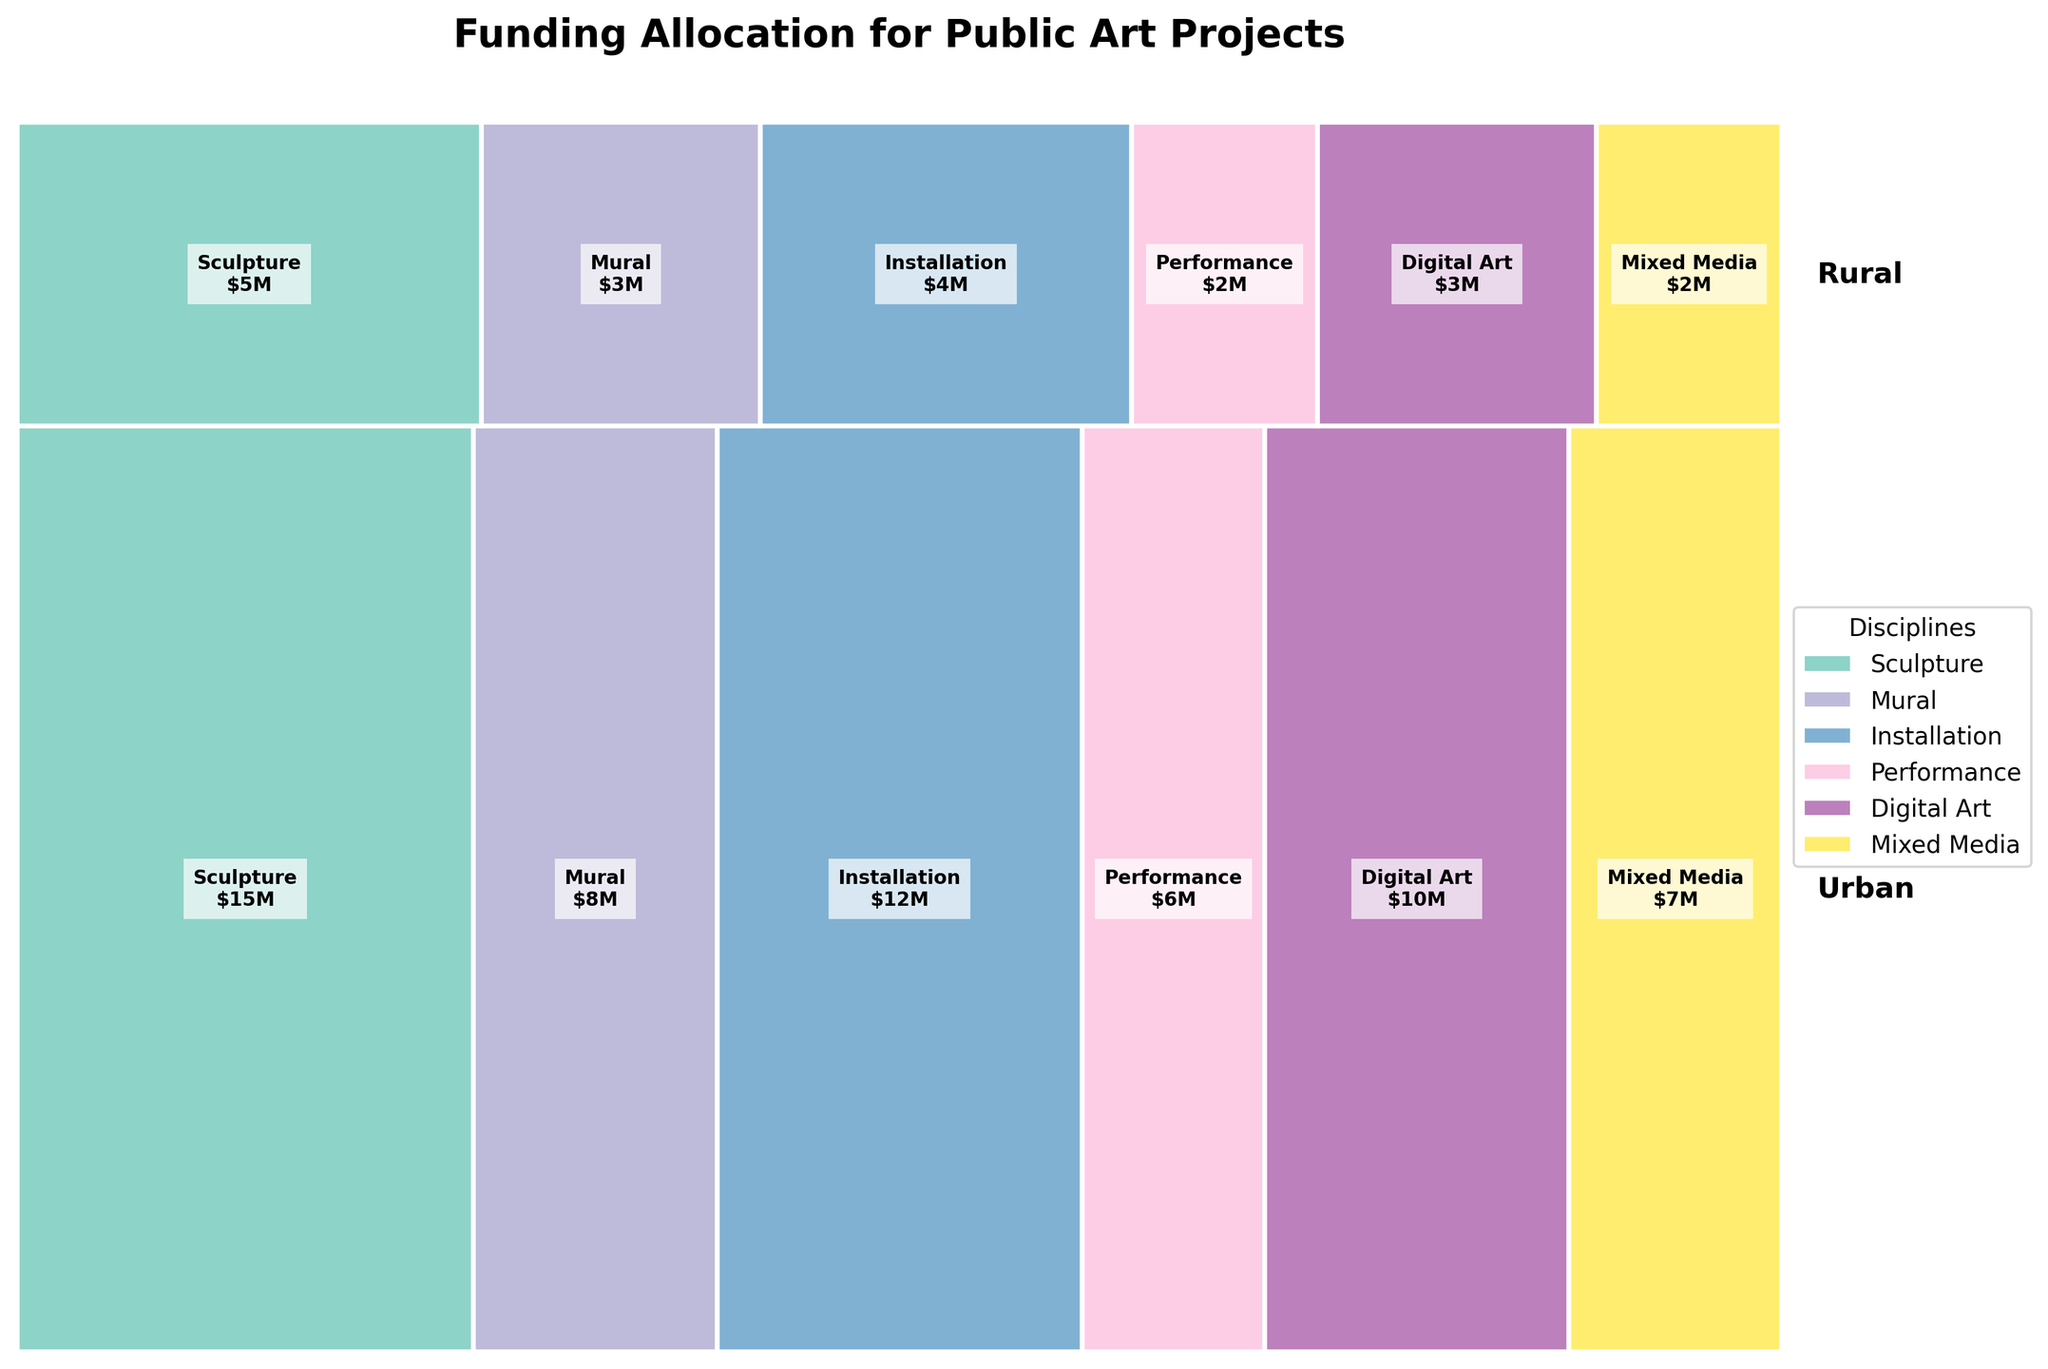what's the title of the figure? The title is located at the top of the figure and usually describes the main topic or message of the plot. It helps viewers understand the context.
Answer: Funding Allocation for Public Art Projects Which area received more total funding, Urban or Rural? Compare the total areas occupied by the sections labeled 'Urban' and 'Rural'. The total height of the 'Urban' sections is larger than that of the 'Rural' sections, indicating more total funding.
Answer: Urban What is the discipline with the highest funding in Urban areas? Within the 'Urban' sections, locate the section with the largest width. The section labeled 'Sculpture' is the widest, indicating it has the highest funding.
Answer: Sculpture Compare the funding allocated to Digital Art in Urban areas vs. Rural areas. Which one received more, and by how much? Check the sections labeled 'Digital Art' in both 'Urban' and 'Rural' areas. The 'Urban' section is wider, representing more funding. The difference is $10M - $3M = $7M.
Answer: Urban by $7M What is the total funding allocated to Mixed Media projects? Locate both 'Urban' and 'Rural' sections labeled 'Mixed Media' and add their funding values: $7M (Urban) + $2M (Rural) = $9M.
Answer: $9M How does the funding for Sculpture compare between Urban and Rural areas? For 'Sculpture', compare the widths of 'Urban' and 'Rural' sections. Urban's section is significantly wider than Rural's. $15M (Urban) vs. $5M (Rural), so Urban has $10M more.
Answer: Urban is $10M more Which discipline received the least amount of funding in Rural areas? Among the 'Rural' sections, identify the one with the smallest width. The section labeled 'Performance' is the smallest, implying it received the least funding.
Answer: Performance What's the combined funding for Murals in both Urban and Rural areas? Add the funding values for Murals in both 'Urban' and 'Rural' sections: $8M (Urban) + $3M (Rural) = $11M.
Answer: $11M Is there any discipline where the funding is equal between Urban and Rural areas? Compare the funding amounts for each discipline between 'Urban' and 'Rural' sections. No discipline has equal width sections in both areas.
Answer: No What portion of the total funding is allocated to Installation projects? Sum the funding for Installation projects in 'Urban' and 'Rural' (12M + 4M = 16M), then divide by the total funding across all sections. The total funding is 15 + 8 + 12 + 6 + 5 + 3 + 4 + 2 + 10 + 3 + 7 + 2 = 77M. Thus, the portion is 16M/77M.
Answer: 16/77 